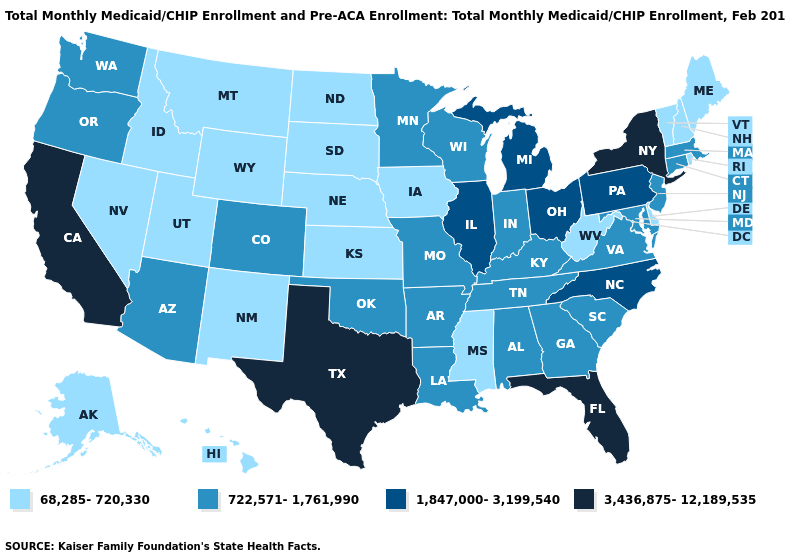Does the first symbol in the legend represent the smallest category?
Short answer required. Yes. Among the states that border Tennessee , does Mississippi have the highest value?
Give a very brief answer. No. Name the states that have a value in the range 68,285-720,330?
Be succinct. Alaska, Delaware, Hawaii, Idaho, Iowa, Kansas, Maine, Mississippi, Montana, Nebraska, Nevada, New Hampshire, New Mexico, North Dakota, Rhode Island, South Dakota, Utah, Vermont, West Virginia, Wyoming. Does Kansas have the lowest value in the USA?
Write a very short answer. Yes. What is the highest value in the USA?
Be succinct. 3,436,875-12,189,535. Among the states that border Kentucky , does West Virginia have the lowest value?
Short answer required. Yes. Which states have the lowest value in the USA?
Short answer required. Alaska, Delaware, Hawaii, Idaho, Iowa, Kansas, Maine, Mississippi, Montana, Nebraska, Nevada, New Hampshire, New Mexico, North Dakota, Rhode Island, South Dakota, Utah, Vermont, West Virginia, Wyoming. What is the value of New Jersey?
Quick response, please. 722,571-1,761,990. Among the states that border Alabama , which have the highest value?
Be succinct. Florida. What is the lowest value in states that border New Mexico?
Quick response, please. 68,285-720,330. Does New Mexico have the same value as Delaware?
Short answer required. Yes. Name the states that have a value in the range 3,436,875-12,189,535?
Write a very short answer. California, Florida, New York, Texas. Among the states that border North Dakota , which have the lowest value?
Quick response, please. Montana, South Dakota. Does the map have missing data?
Quick response, please. No. What is the value of New Mexico?
Concise answer only. 68,285-720,330. 